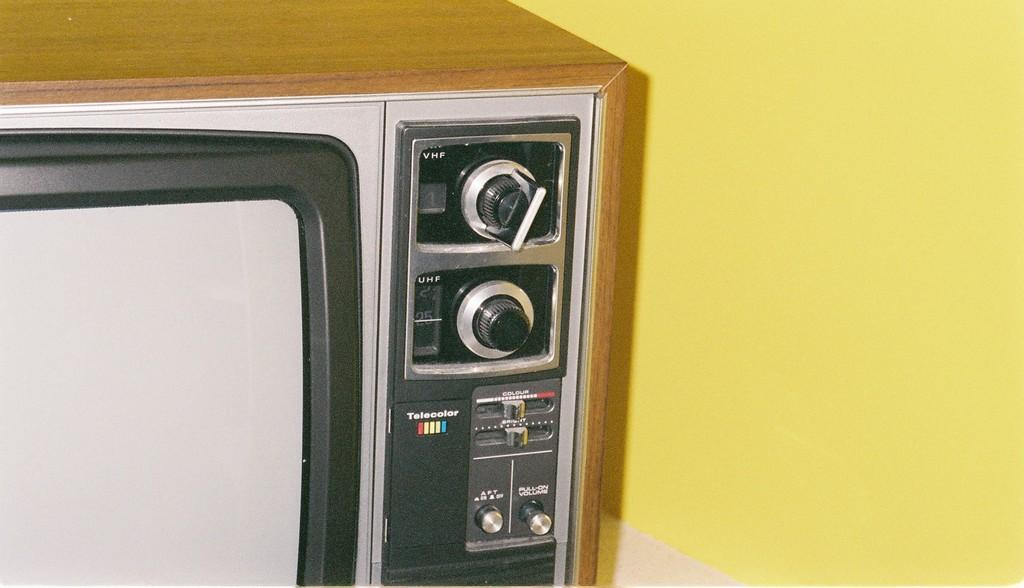<image>
Describe the image concisely. A TV that has a Telecolor logo on it. 